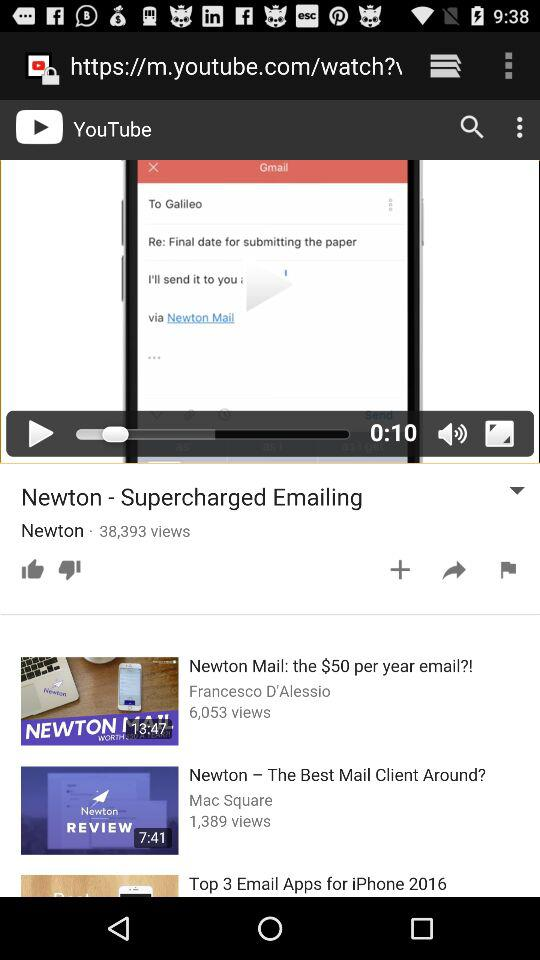How many views are there of "Newton - Supercharged Emailing"? There are 38,393 views. 